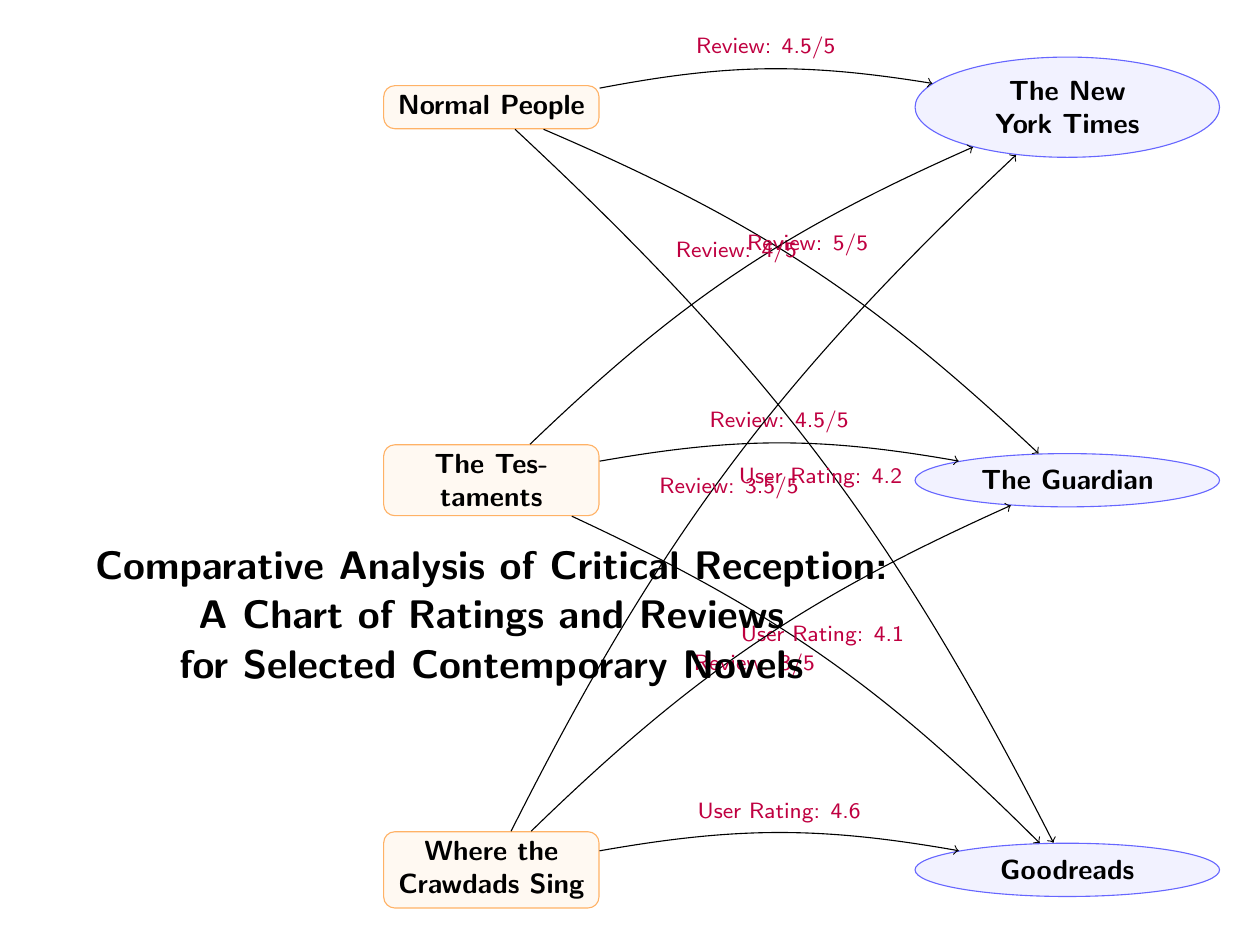What is the rating given to "Normal People" by The New York Times? The diagram shows an edge from "Normal People" to "The New York Times" with the label "Review: 4.5/5". Therefore, the rating is directly stated in this edge.
Answer: 4.5/5 What is the User Rating for "Where the Crawdads Sing" on Goodreads? In the diagram, there is an edge from "Where the Crawdads Sing" to "Goodreads" labelled "User Rating: 4.6". This indicates the specific user rating for that book.
Answer: 4.6 How many books are represented in the diagram? There are three nodes representing books: "Normal People", "The Testaments", and "Where the Crawdads Sing". Thus, counting these nodes provides the total number of books.
Answer: 3 Which book has the highest User Rating? To determine this, we compare the User Ratings: "Normal People" has 4.2, "The Testaments" has 4.1, and "Where the Crawdads Sing" has 4.6. The highest of these is 4.6 from "Where the Crawdads Sing".
Answer: Where the Crawdads Sing What two critics reviewed "The Testaments"? The diagram shows edges from "The Testaments" to both "The New York Times" (Review: 4/5) and "The Guardian" (Review: 4.5/5). Thus, the critics that reviewed this book are indicated by these connections.
Answer: The New York Times and The Guardian What is the relationship between "Normal People" and "Goodreads"? There is an edge from "Normal People" to "Goodreads" labelled "User Rating: 4.2", indicating there is a user rating for the book on this platform. Thus, the relationship is established through this connection.
Answer: User Rating Which book received the lowest critical review score from The Guardian? Evaluating the critical reviews from The Guardian: "Normal People" received 5/5, "The Testaments" received 4.5/5, and "Where the Crawdads Sing" received 3/5. The lowest score among these is 3/5 for "Where the Crawdads Sing".
Answer: Where the Crawdads Sing How is the "Comparative Analysis of Critical Reception" illustrated in the diagram? The diagram uses a visual structure of books connected to their reviewers, with lines indicating reviews and ratings. This illustrates how each book's critical reception varies among different critics.
Answer: Through nodes and edges What overall theme does this diagram represent? The diagram represents the critical reception of selected contemporary novels by showing ratings and reviews from different critics, allowing for a comparative analysis of these elements.
Answer: Critical Reception Analysis 